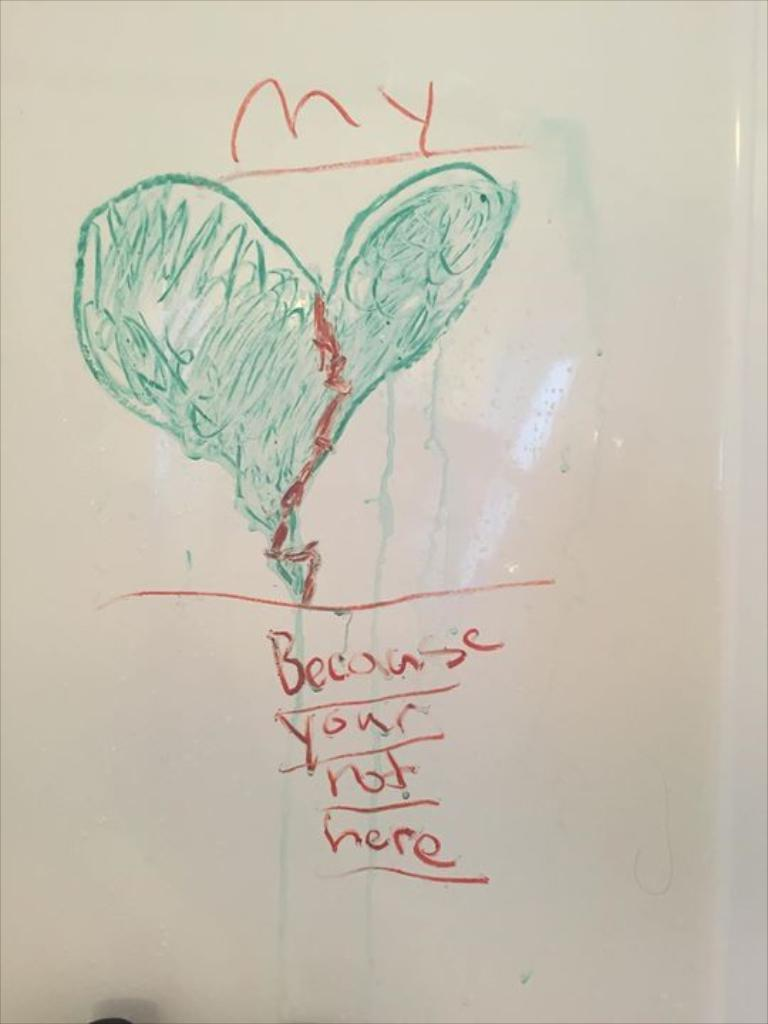<image>
Render a clear and concise summary of the photo. A scrawled drawing of a green heart and the word my on top of it. 